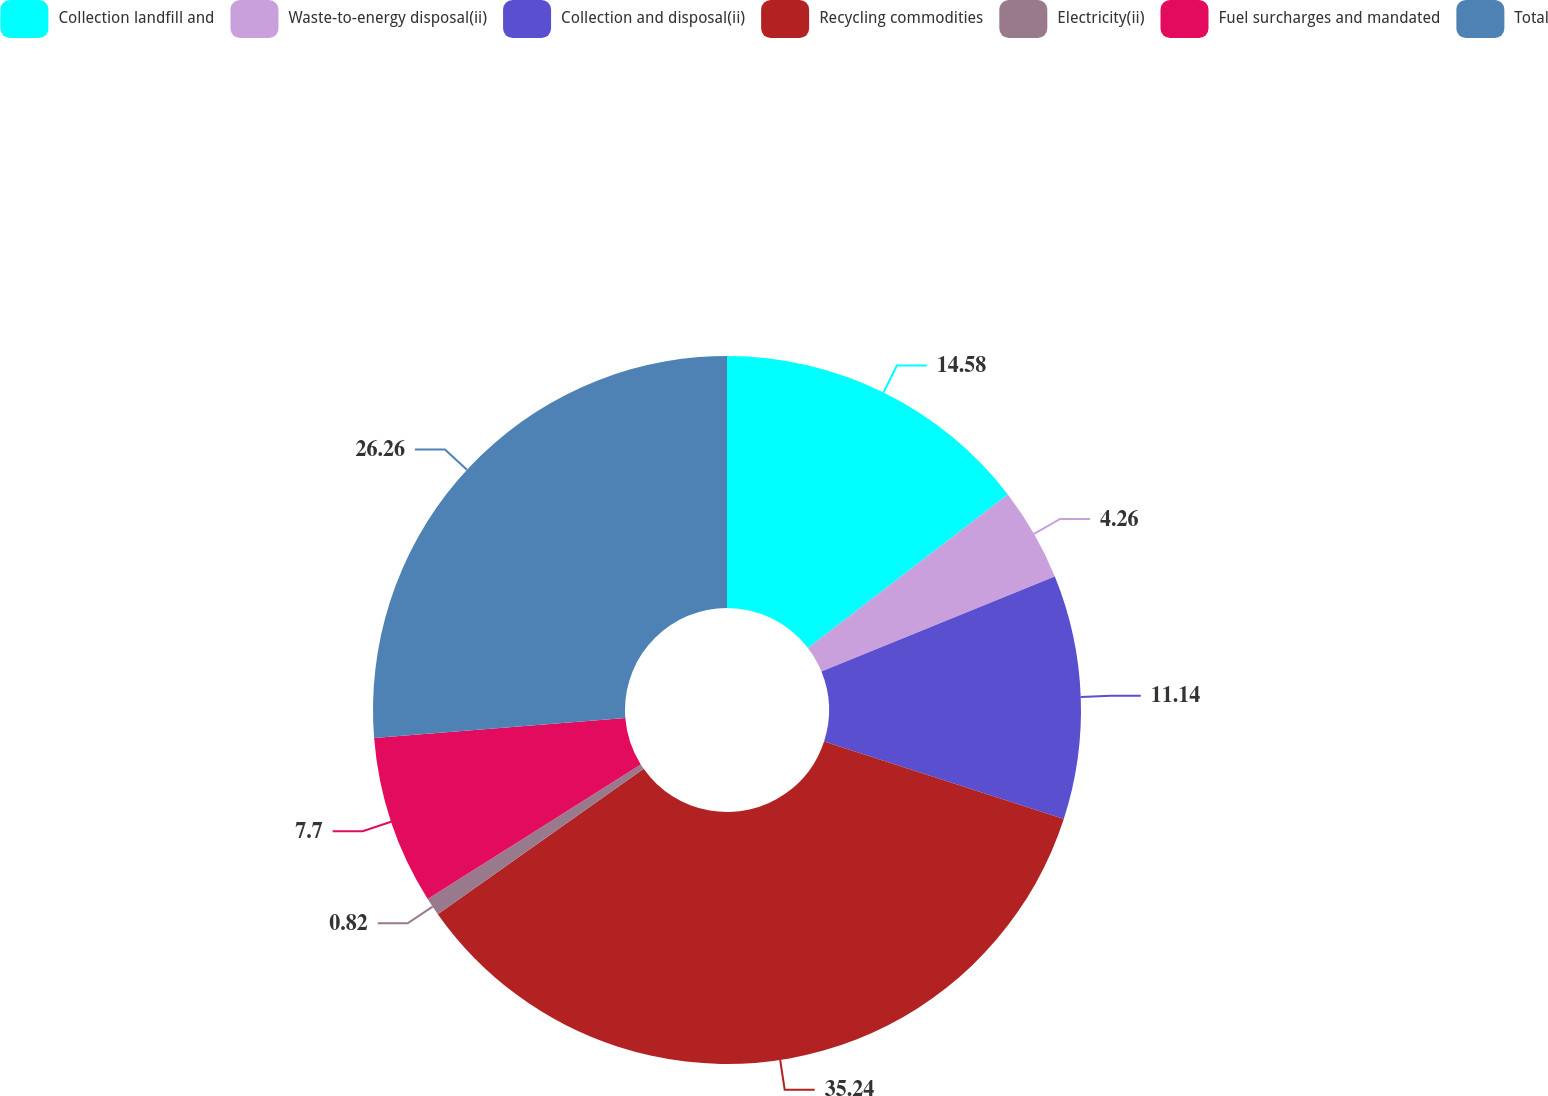Convert chart to OTSL. <chart><loc_0><loc_0><loc_500><loc_500><pie_chart><fcel>Collection landfill and<fcel>Waste-to-energy disposal(ii)<fcel>Collection and disposal(ii)<fcel>Recycling commodities<fcel>Electricity(ii)<fcel>Fuel surcharges and mandated<fcel>Total<nl><fcel>14.58%<fcel>4.26%<fcel>11.14%<fcel>35.23%<fcel>0.82%<fcel>7.7%<fcel>26.26%<nl></chart> 